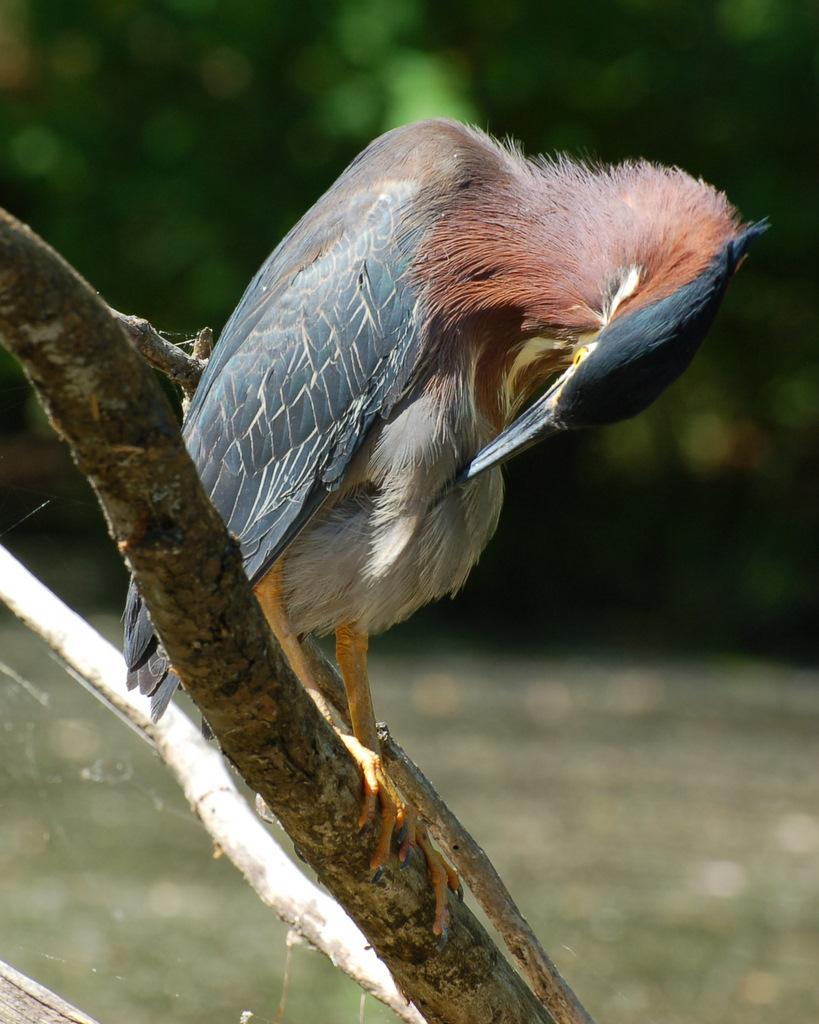What type of animal can be seen in the image? There is a bird in the image. Where is the bird located in the image? The bird is on a branch. What can be said about the background of the image? The background of the image is blurred and green. What type of teeth can be seen on the bird in the image? Birds do not have teeth, so there are no teeth visible on the bird in the image. 